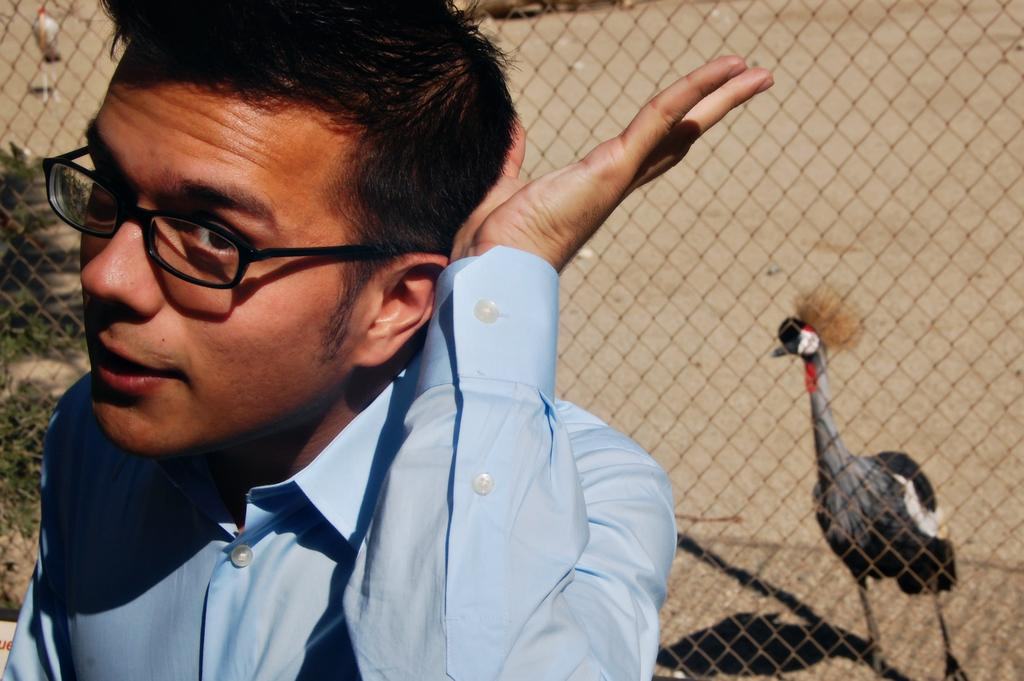Who or what is present in the image? There is a person in the image. What type of animals can be seen in the image? Birds are visible in the image. What other living organisms can be seen in the image? Plants are present in the image. What architectural feature can be seen in the image? There is a fence in the image. What is the name of the pear that is being held by the person in the image? There is no pear present in the image, and the person is not holding any fruit. 